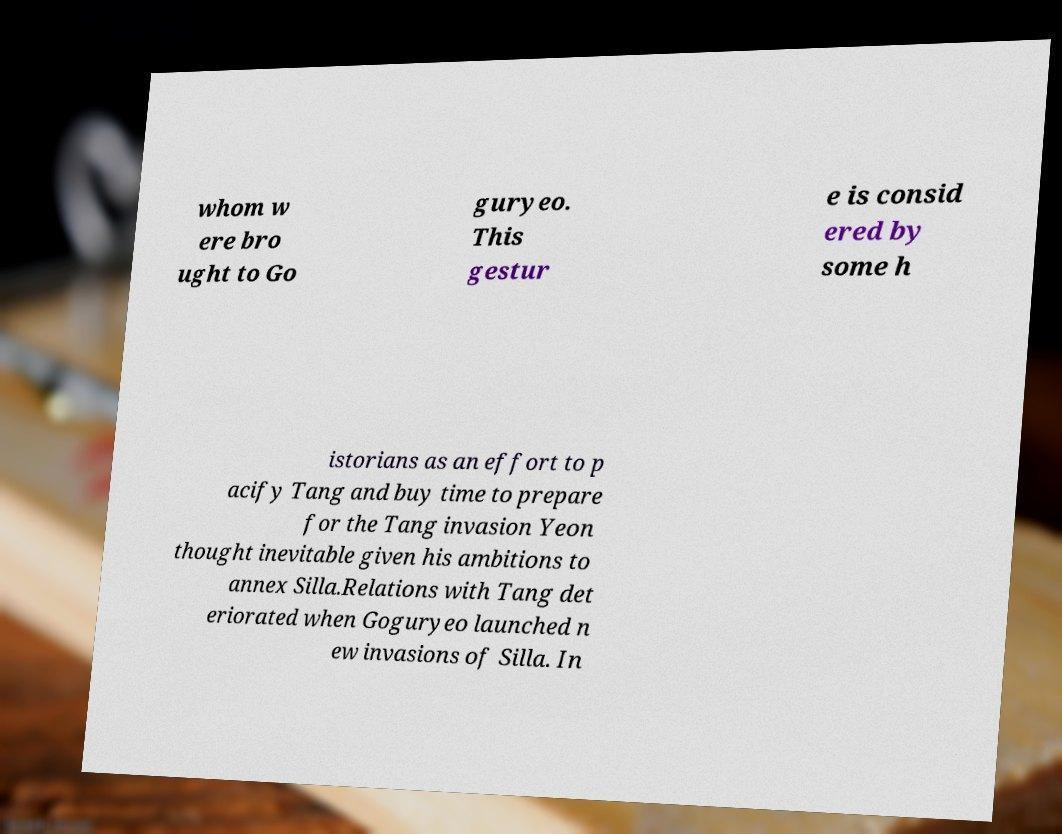Can you read and provide the text displayed in the image?This photo seems to have some interesting text. Can you extract and type it out for me? whom w ere bro ught to Go guryeo. This gestur e is consid ered by some h istorians as an effort to p acify Tang and buy time to prepare for the Tang invasion Yeon thought inevitable given his ambitions to annex Silla.Relations with Tang det eriorated when Goguryeo launched n ew invasions of Silla. In 